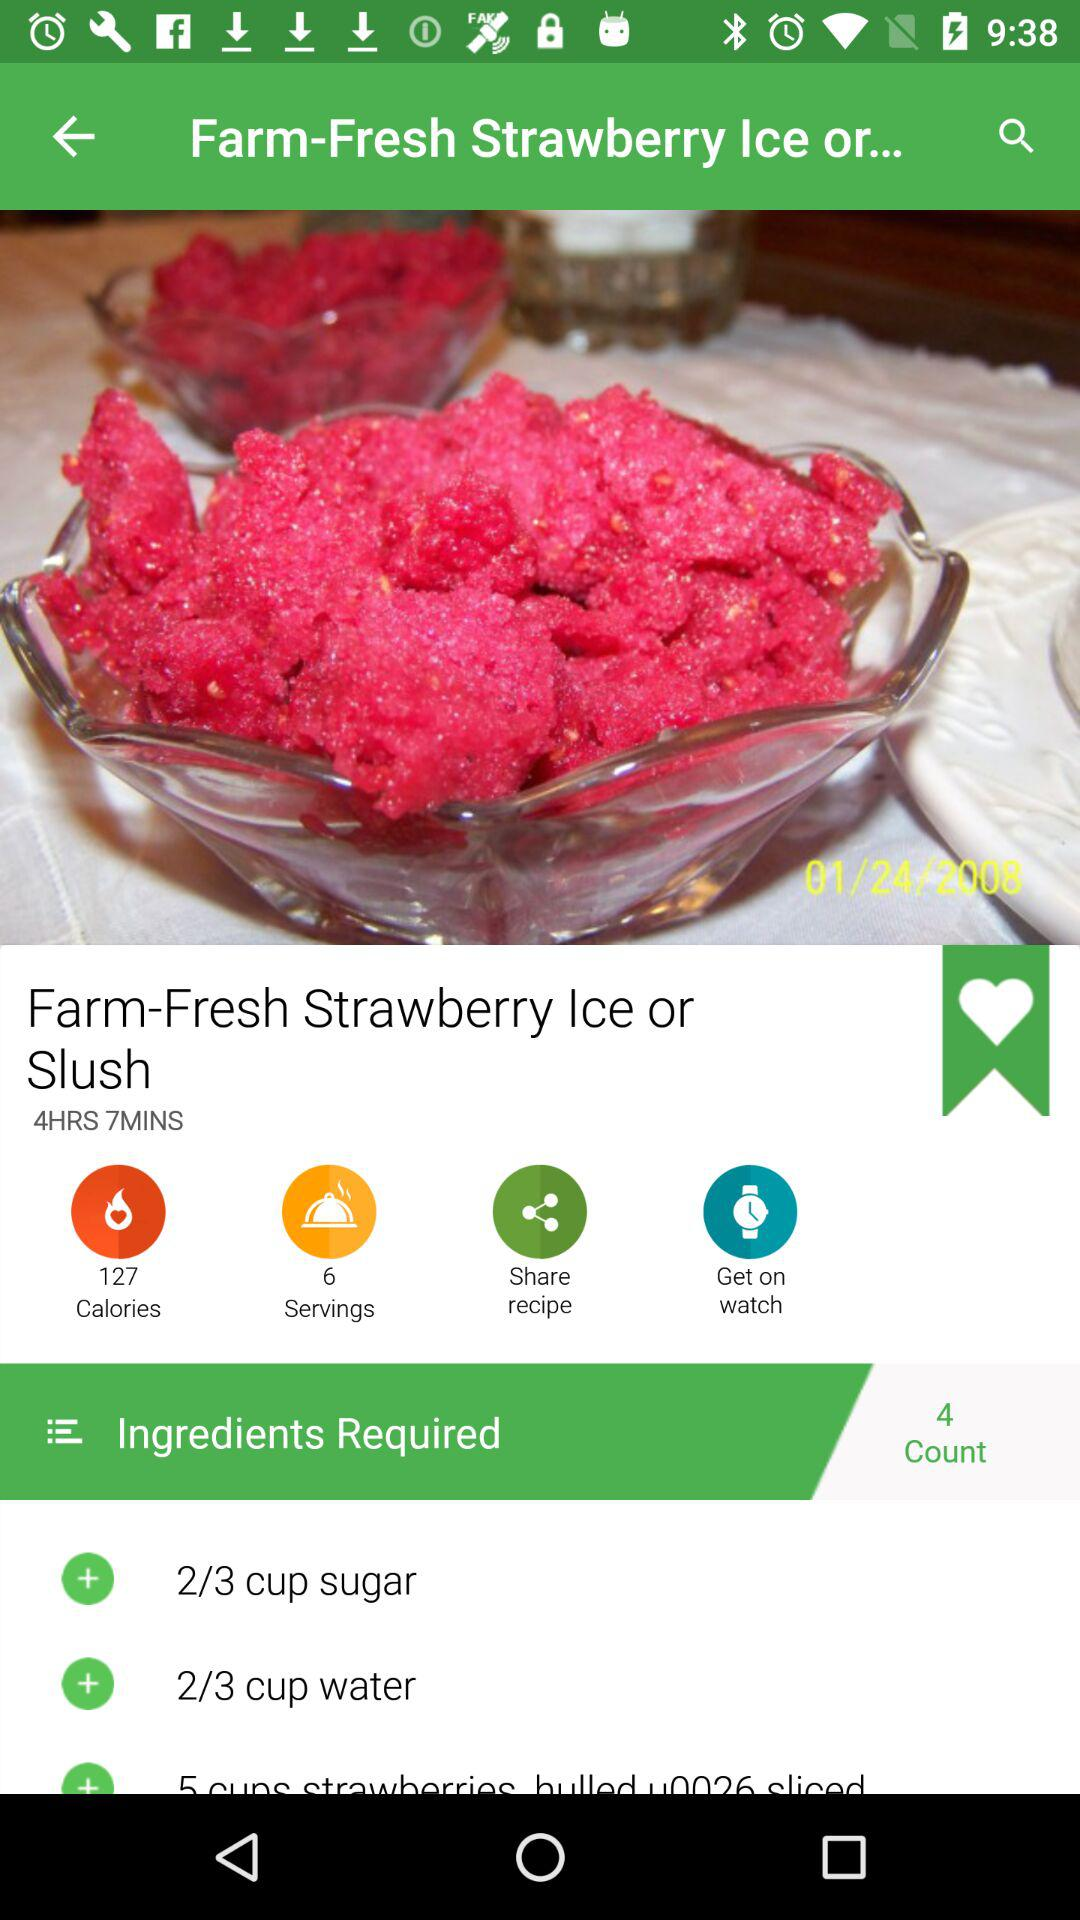What is the amount of sugar required in the dish? The amount of sugar required in the dish is 2/3 cup. 